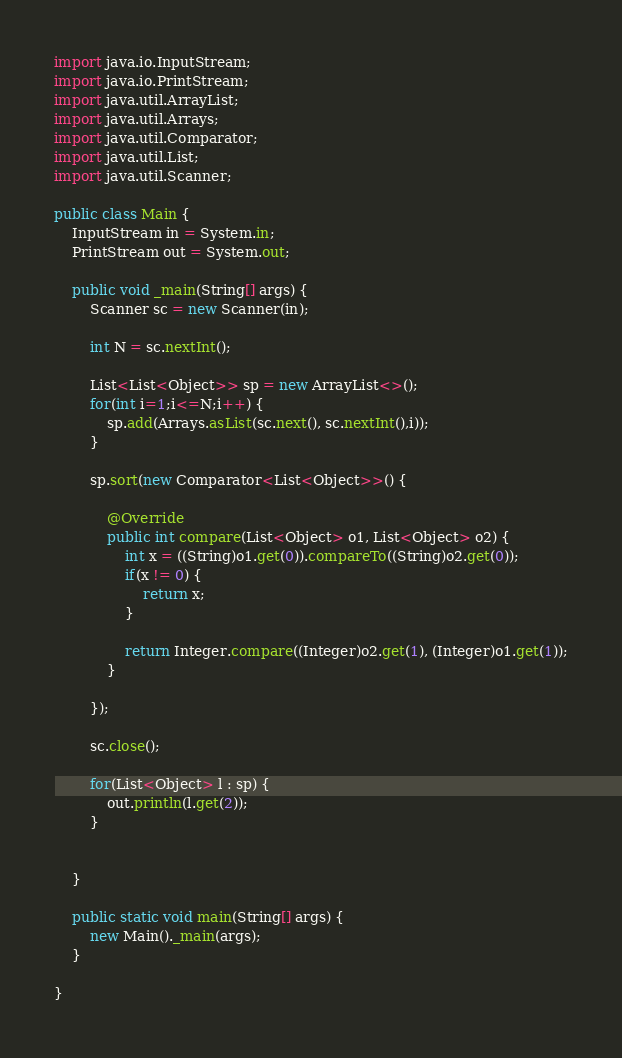<code> <loc_0><loc_0><loc_500><loc_500><_Java_>import java.io.InputStream;
import java.io.PrintStream;
import java.util.ArrayList;
import java.util.Arrays;
import java.util.Comparator;
import java.util.List;
import java.util.Scanner;

public class Main {
	InputStream in = System.in;
	PrintStream out = System.out;

	public void _main(String[] args) {
		Scanner sc = new Scanner(in);

		int N = sc.nextInt();
		
		List<List<Object>> sp = new ArrayList<>();
		for(int i=1;i<=N;i++) {
			sp.add(Arrays.asList(sc.next(), sc.nextInt(),i));
		}
		
		sp.sort(new Comparator<List<Object>>() {

			@Override
			public int compare(List<Object> o1, List<Object> o2) {
				int x = ((String)o1.get(0)).compareTo((String)o2.get(0));
				if(x != 0) {
					return x;
				}
				
				return Integer.compare((Integer)o2.get(1), (Integer)o1.get(1));
			}
			
		});
		
		sc.close();

		for(List<Object> l : sp) {
			out.println(l.get(2));
		}
		
		
	}

	public static void main(String[] args) {
		new Main()._main(args);
	}

}
</code> 